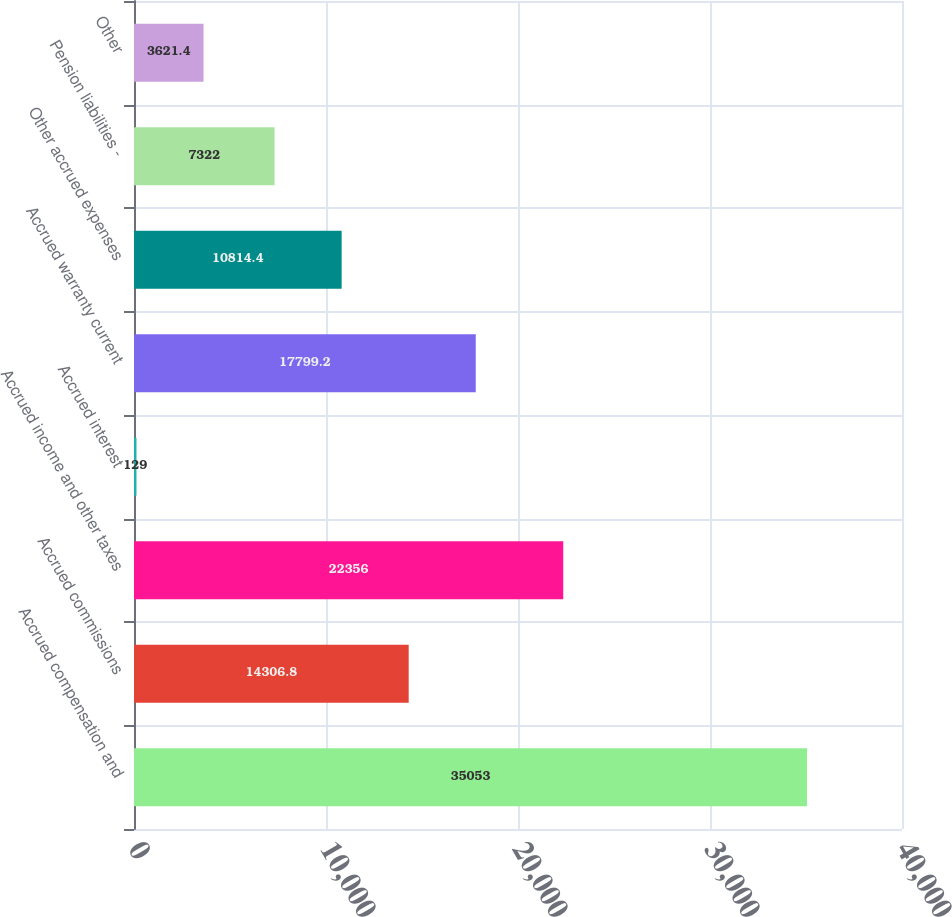Convert chart to OTSL. <chart><loc_0><loc_0><loc_500><loc_500><bar_chart><fcel>Accrued compensation and<fcel>Accrued commissions<fcel>Accrued income and other taxes<fcel>Accrued interest<fcel>Accrued warranty current<fcel>Other accrued expenses<fcel>Pension liabilities -<fcel>Other<nl><fcel>35053<fcel>14306.8<fcel>22356<fcel>129<fcel>17799.2<fcel>10814.4<fcel>7322<fcel>3621.4<nl></chart> 